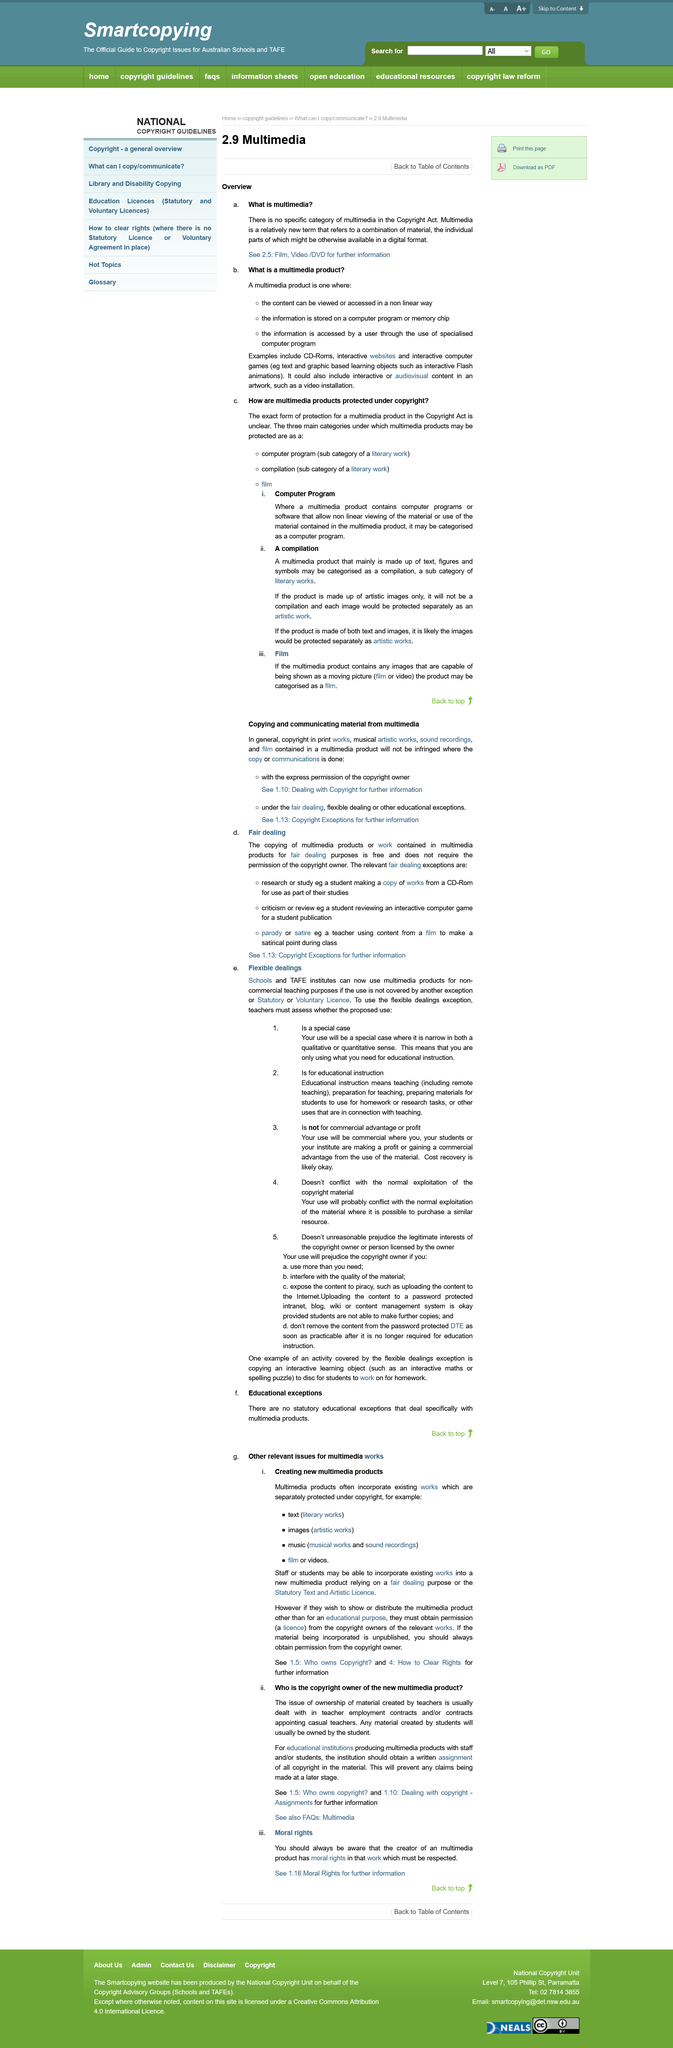Identify some key points in this picture. Multimedia products that incorporate existing works protected by copyright, such as text, images, music, films, and videos, are subject to copyright law. A film is a multimedia product that contains any images that are capable of being shown as a moving picture (film or video). Yes, the creator of multimedia products has moral rights that should be respected. It is not permissible to use the flexible dealings exception if the use is already covered by a voluntary license. It is not necessary to obtain permission from the copyright owner in order to copy multimedia products for fair dealing purposes. 